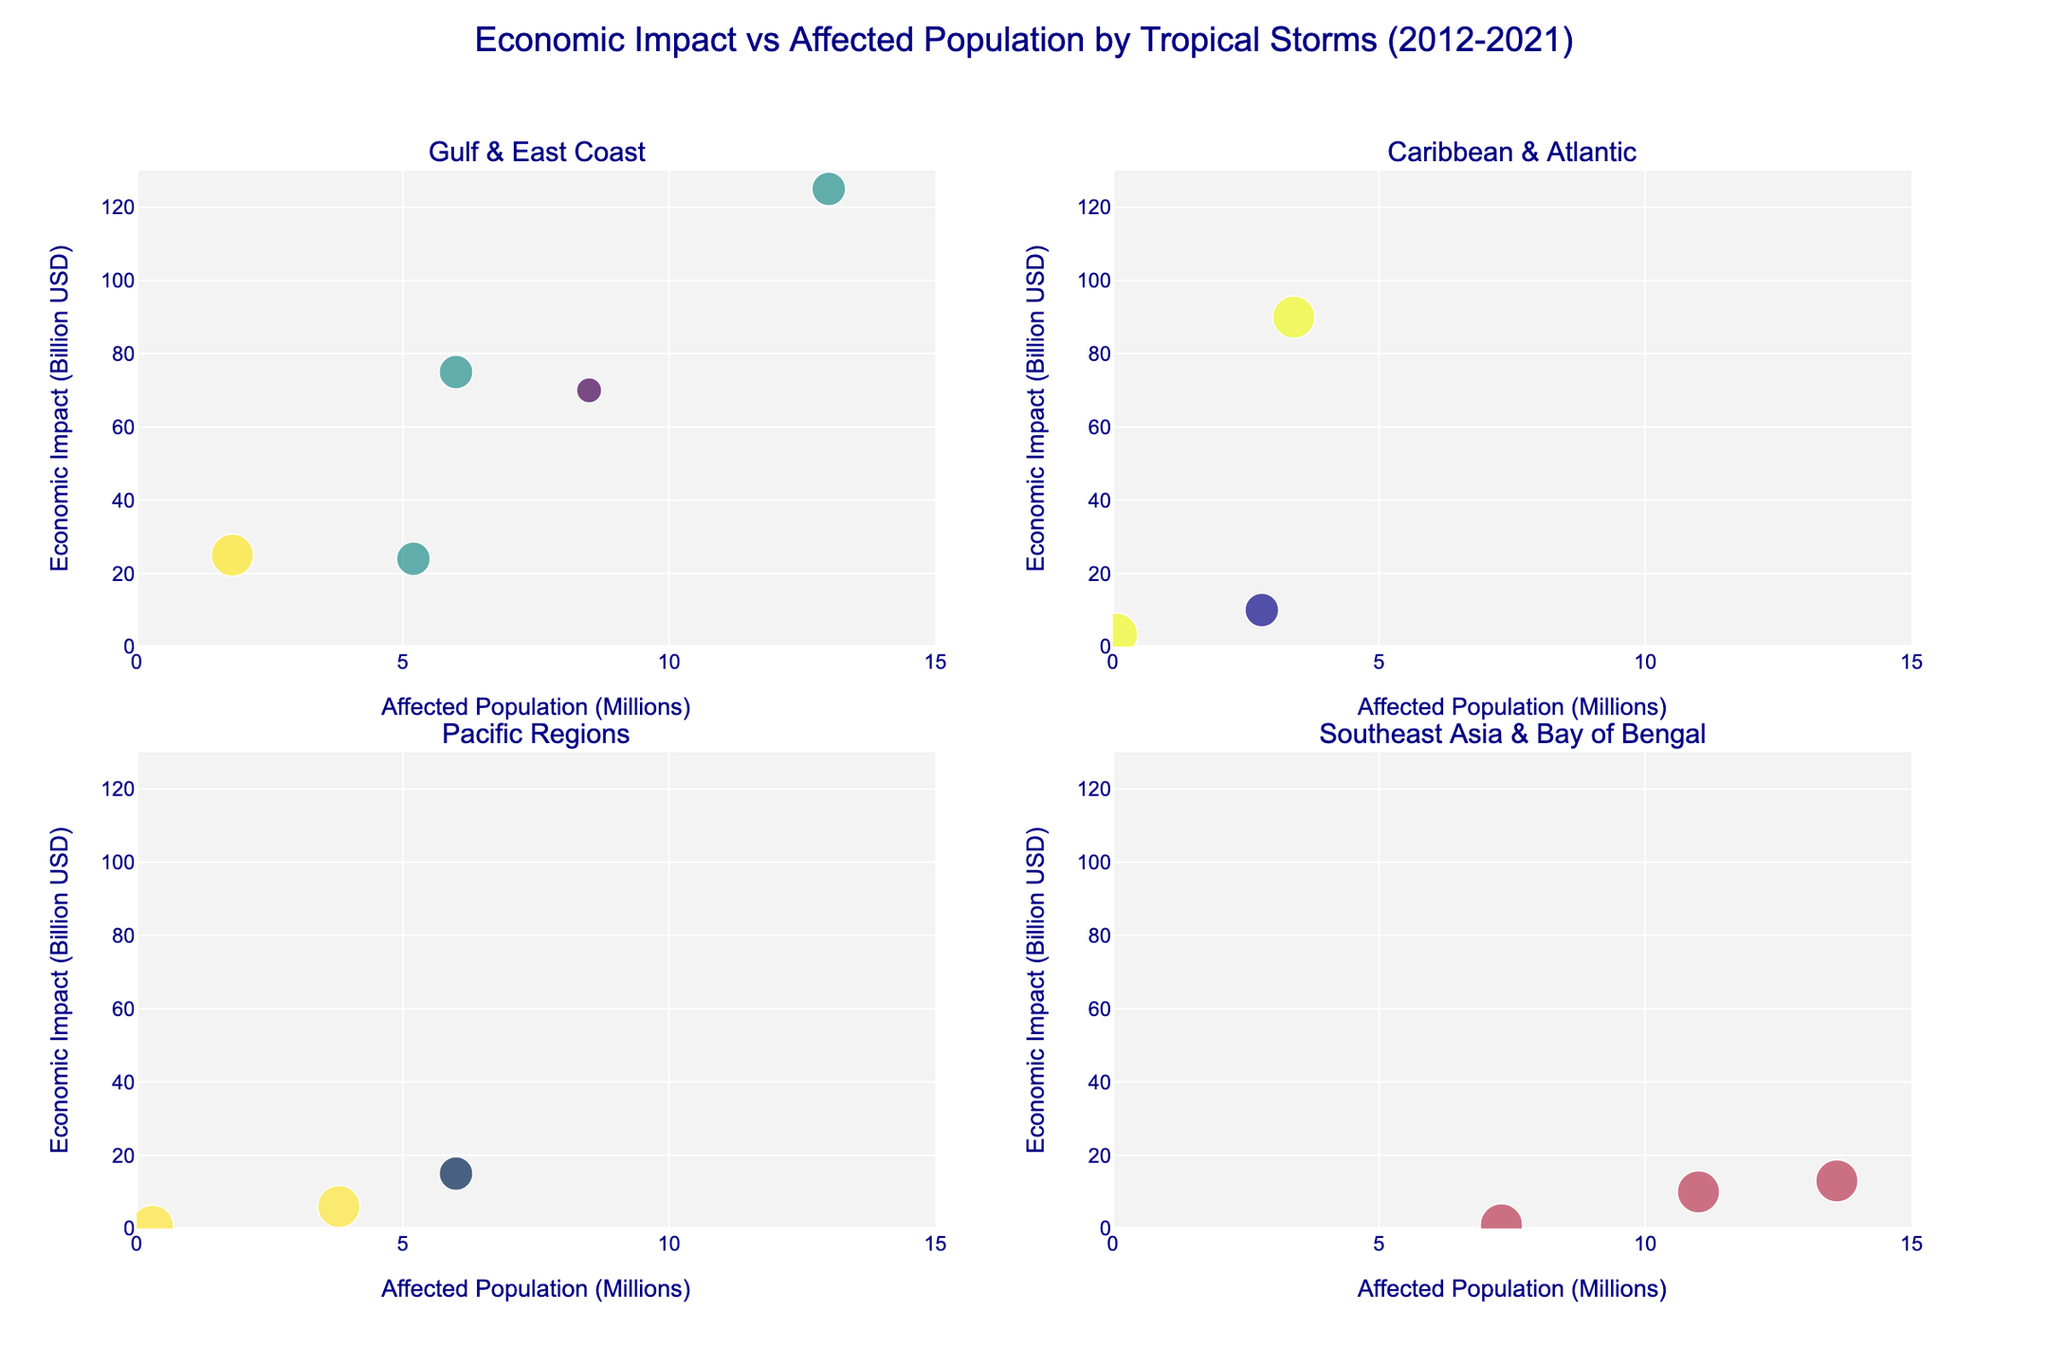Which region experienced the highest economic impact from tropical storms? Look at the bubble plot and identify the region with the data point that has the highest value on the y-axis. The 'Gulf & East Coast' subplot contains Hurricane Harvey with an economic impact of $125 billion.
Answer: Gulf & East Coast How many tropical storms affected less than 1 million people? Count the number of bubbles with x-axis values less than 1 in all subplots. There are two such storms: Cyclone Pam and Hurricane Dorian.
Answer: 2 Which storm had the highest impact per affected population? Calculate the economic impact per affected population for each storm and compare them. Hurricane Dorian had a $3.4 billion impact with 0.07 million people affected, giving an impact per affected population of approximately 48.57.
Answer: Hurricane Dorian Between Hurricane Sandy and Hurricane Maria, which had a higher economic impact and how much higher? Compare their economic impacts. Hurricane Sandy had $70 billion, and Hurricane Maria had $90 billion. The difference is $90 billion - $70 billion = $20 billion.
Answer: Hurricane Maria, $20 billion In the Pacific Regions, which storm had the highest category? In the Pacific Regions subplot, identify the storm with the largest bubble size representing the highest category. Both Cyclone Pam and Typhoon Mangkhut are Category 5, but Cyclone Pam is higher in economic impact.
Answer: Cyclone Pam What is the total economic impact caused by the storms in Southeast Asia and Bay of Bengal? Sum up the economic impacts from Southeast Asia and Bay of Bengal in the 'Southeast Asia & Bay of Bengal' subplot: Typhoon Haiyan ($10 billion), Typhoon Rai ($1 billion), and Cyclone Amphan ($13 billion). The total is $10 billion + $1 billion + $13 billion = $24 billion.
Answer: $24 billion Which storm affected the largest population in the Gulf & East Coast region? In the 'Gulf & East Coast' subplot, identify the storm with the highest value on the x-axis representing affected population. Hurricane Harvey affected 13 million people.
Answer: Hurricane Harvey How does the economic impact per affected population for Hurricane Michael compare to Typhoon Hagibis? Calculate the impact per population for both storms and compare. Hurricane Michael's impact per million is $25 billion / 1.8 million = 13.89. Typhoon Hagibis' impact per million is $15 billion / 6 million = 2.5. Hurricane Michael has a higher impact per population.
Answer: Hurricane Michael Which subplot contains the storm with the lowest economic impact? Look for the smallest data point on the y-axis across all subplots. The 'Pacific Regions' subplot contains Cyclone Pam with an economic impact of $0.6 billion.
Answer: Pacific Regions What is the range of affected populations in the Caribbean & Atlantic subplot? Identify the smallest and largest x-axis values in the Caribbean & Atlantic subplot. The smallest is Hurricane Dorian (0.07 million), and the largest is Hurricane Sandy (8.5 million). The range is 8.5 million - 0.07 million = 8.43 million.
Answer: 8.43 million 